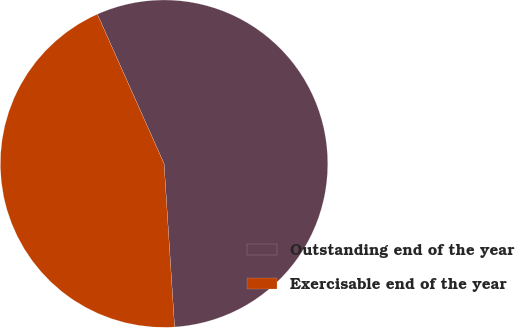Convert chart to OTSL. <chart><loc_0><loc_0><loc_500><loc_500><pie_chart><fcel>Outstanding end of the year<fcel>Exercisable end of the year<nl><fcel>55.66%<fcel>44.34%<nl></chart> 